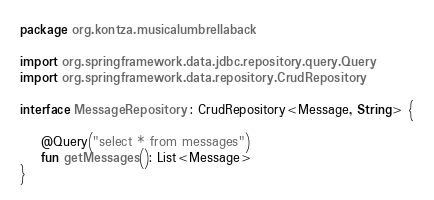Convert code to text. <code><loc_0><loc_0><loc_500><loc_500><_Kotlin_>package org.kontza.musicalumbrellaback

import org.springframework.data.jdbc.repository.query.Query
import org.springframework.data.repository.CrudRepository

interface MessageRepository : CrudRepository<Message, String> {

    @Query("select * from messages")
    fun getMessages(): List<Message>
}
</code> 